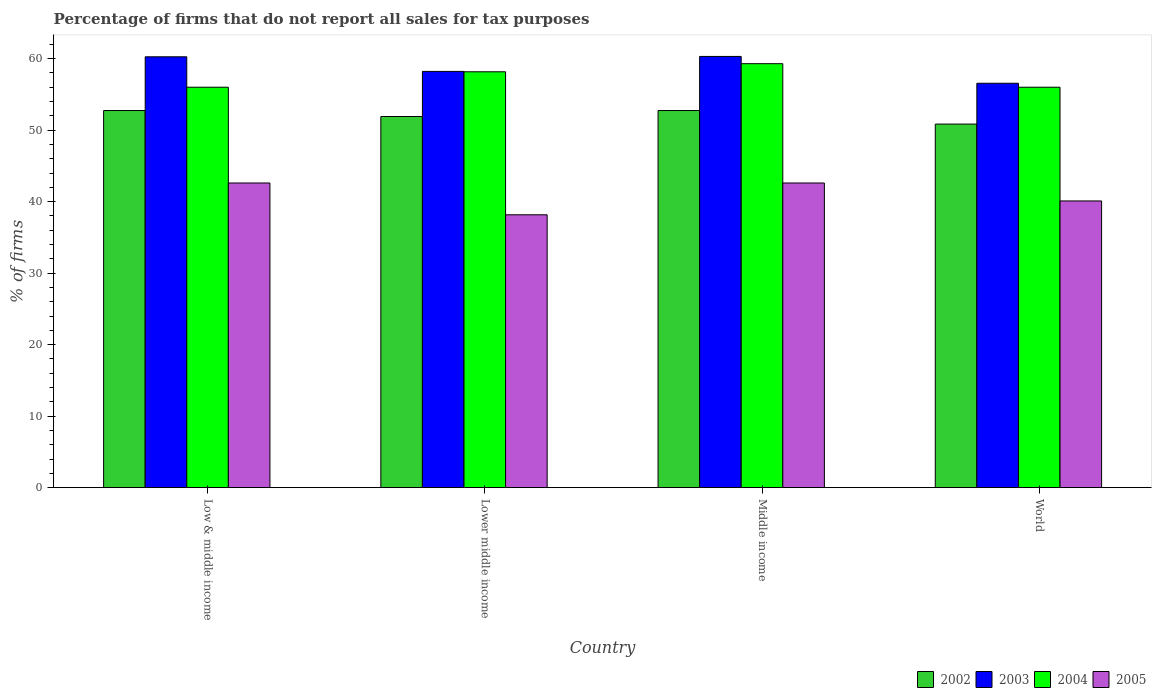Are the number of bars per tick equal to the number of legend labels?
Keep it short and to the point. Yes. Are the number of bars on each tick of the X-axis equal?
Your response must be concise. Yes. How many bars are there on the 4th tick from the right?
Offer a very short reply. 4. What is the label of the 3rd group of bars from the left?
Make the answer very short. Middle income. What is the percentage of firms that do not report all sales for tax purposes in 2005 in Middle income?
Give a very brief answer. 42.61. Across all countries, what is the maximum percentage of firms that do not report all sales for tax purposes in 2003?
Keep it short and to the point. 60.31. Across all countries, what is the minimum percentage of firms that do not report all sales for tax purposes in 2004?
Offer a very short reply. 56.01. In which country was the percentage of firms that do not report all sales for tax purposes in 2005 maximum?
Make the answer very short. Low & middle income. What is the total percentage of firms that do not report all sales for tax purposes in 2003 in the graph?
Offer a very short reply. 235.35. What is the difference between the percentage of firms that do not report all sales for tax purposes in 2003 in Low & middle income and that in Lower middle income?
Give a very brief answer. 2.04. What is the difference between the percentage of firms that do not report all sales for tax purposes in 2004 in Low & middle income and the percentage of firms that do not report all sales for tax purposes in 2002 in World?
Offer a terse response. 5.15. What is the average percentage of firms that do not report all sales for tax purposes in 2004 per country?
Your answer should be very brief. 57.37. What is the difference between the percentage of firms that do not report all sales for tax purposes of/in 2003 and percentage of firms that do not report all sales for tax purposes of/in 2005 in World?
Offer a very short reply. 16.46. What is the ratio of the percentage of firms that do not report all sales for tax purposes in 2002 in Low & middle income to that in World?
Offer a very short reply. 1.04. Is the percentage of firms that do not report all sales for tax purposes in 2003 in Lower middle income less than that in World?
Provide a short and direct response. No. What is the difference between the highest and the second highest percentage of firms that do not report all sales for tax purposes in 2003?
Your answer should be compact. -2.09. What is the difference between the highest and the lowest percentage of firms that do not report all sales for tax purposes in 2005?
Keep it short and to the point. 4.45. Is it the case that in every country, the sum of the percentage of firms that do not report all sales for tax purposes in 2003 and percentage of firms that do not report all sales for tax purposes in 2002 is greater than the sum of percentage of firms that do not report all sales for tax purposes in 2004 and percentage of firms that do not report all sales for tax purposes in 2005?
Make the answer very short. Yes. What does the 2nd bar from the left in Lower middle income represents?
Provide a succinct answer. 2003. Is it the case that in every country, the sum of the percentage of firms that do not report all sales for tax purposes in 2005 and percentage of firms that do not report all sales for tax purposes in 2003 is greater than the percentage of firms that do not report all sales for tax purposes in 2002?
Give a very brief answer. Yes. Are all the bars in the graph horizontal?
Keep it short and to the point. No. Are the values on the major ticks of Y-axis written in scientific E-notation?
Your answer should be very brief. No. Does the graph contain any zero values?
Your response must be concise. No. Does the graph contain grids?
Ensure brevity in your answer.  No. What is the title of the graph?
Ensure brevity in your answer.  Percentage of firms that do not report all sales for tax purposes. What is the label or title of the Y-axis?
Your answer should be very brief. % of firms. What is the % of firms of 2002 in Low & middle income?
Offer a terse response. 52.75. What is the % of firms in 2003 in Low & middle income?
Offer a terse response. 60.26. What is the % of firms of 2004 in Low & middle income?
Give a very brief answer. 56.01. What is the % of firms in 2005 in Low & middle income?
Make the answer very short. 42.61. What is the % of firms in 2002 in Lower middle income?
Ensure brevity in your answer.  51.91. What is the % of firms of 2003 in Lower middle income?
Your response must be concise. 58.22. What is the % of firms in 2004 in Lower middle income?
Give a very brief answer. 58.16. What is the % of firms of 2005 in Lower middle income?
Provide a succinct answer. 38.16. What is the % of firms of 2002 in Middle income?
Give a very brief answer. 52.75. What is the % of firms in 2003 in Middle income?
Keep it short and to the point. 60.31. What is the % of firms in 2004 in Middle income?
Offer a terse response. 59.3. What is the % of firms in 2005 in Middle income?
Provide a short and direct response. 42.61. What is the % of firms in 2002 in World?
Provide a short and direct response. 50.85. What is the % of firms in 2003 in World?
Your answer should be compact. 56.56. What is the % of firms of 2004 in World?
Your answer should be compact. 56.01. What is the % of firms of 2005 in World?
Ensure brevity in your answer.  40.1. Across all countries, what is the maximum % of firms of 2002?
Offer a very short reply. 52.75. Across all countries, what is the maximum % of firms in 2003?
Your response must be concise. 60.31. Across all countries, what is the maximum % of firms in 2004?
Your answer should be compact. 59.3. Across all countries, what is the maximum % of firms of 2005?
Make the answer very short. 42.61. Across all countries, what is the minimum % of firms in 2002?
Your response must be concise. 50.85. Across all countries, what is the minimum % of firms of 2003?
Your answer should be compact. 56.56. Across all countries, what is the minimum % of firms of 2004?
Provide a succinct answer. 56.01. Across all countries, what is the minimum % of firms in 2005?
Offer a terse response. 38.16. What is the total % of firms of 2002 in the graph?
Offer a terse response. 208.25. What is the total % of firms of 2003 in the graph?
Offer a very short reply. 235.35. What is the total % of firms in 2004 in the graph?
Make the answer very short. 229.47. What is the total % of firms of 2005 in the graph?
Offer a terse response. 163.48. What is the difference between the % of firms of 2002 in Low & middle income and that in Lower middle income?
Make the answer very short. 0.84. What is the difference between the % of firms in 2003 in Low & middle income and that in Lower middle income?
Offer a very short reply. 2.04. What is the difference between the % of firms in 2004 in Low & middle income and that in Lower middle income?
Provide a short and direct response. -2.16. What is the difference between the % of firms in 2005 in Low & middle income and that in Lower middle income?
Your response must be concise. 4.45. What is the difference between the % of firms in 2003 in Low & middle income and that in Middle income?
Provide a short and direct response. -0.05. What is the difference between the % of firms of 2004 in Low & middle income and that in Middle income?
Offer a very short reply. -3.29. What is the difference between the % of firms in 2002 in Low & middle income and that in World?
Provide a short and direct response. 1.89. What is the difference between the % of firms of 2005 in Low & middle income and that in World?
Your response must be concise. 2.51. What is the difference between the % of firms in 2002 in Lower middle income and that in Middle income?
Provide a short and direct response. -0.84. What is the difference between the % of firms of 2003 in Lower middle income and that in Middle income?
Offer a very short reply. -2.09. What is the difference between the % of firms of 2004 in Lower middle income and that in Middle income?
Your answer should be very brief. -1.13. What is the difference between the % of firms in 2005 in Lower middle income and that in Middle income?
Keep it short and to the point. -4.45. What is the difference between the % of firms of 2002 in Lower middle income and that in World?
Your response must be concise. 1.06. What is the difference between the % of firms of 2003 in Lower middle income and that in World?
Keep it short and to the point. 1.66. What is the difference between the % of firms of 2004 in Lower middle income and that in World?
Keep it short and to the point. 2.16. What is the difference between the % of firms of 2005 in Lower middle income and that in World?
Your answer should be compact. -1.94. What is the difference between the % of firms in 2002 in Middle income and that in World?
Offer a terse response. 1.89. What is the difference between the % of firms in 2003 in Middle income and that in World?
Offer a terse response. 3.75. What is the difference between the % of firms in 2004 in Middle income and that in World?
Your response must be concise. 3.29. What is the difference between the % of firms in 2005 in Middle income and that in World?
Offer a very short reply. 2.51. What is the difference between the % of firms in 2002 in Low & middle income and the % of firms in 2003 in Lower middle income?
Your response must be concise. -5.47. What is the difference between the % of firms in 2002 in Low & middle income and the % of firms in 2004 in Lower middle income?
Offer a very short reply. -5.42. What is the difference between the % of firms of 2002 in Low & middle income and the % of firms of 2005 in Lower middle income?
Provide a short and direct response. 14.58. What is the difference between the % of firms of 2003 in Low & middle income and the % of firms of 2004 in Lower middle income?
Your response must be concise. 2.1. What is the difference between the % of firms of 2003 in Low & middle income and the % of firms of 2005 in Lower middle income?
Ensure brevity in your answer.  22.1. What is the difference between the % of firms of 2004 in Low & middle income and the % of firms of 2005 in Lower middle income?
Give a very brief answer. 17.84. What is the difference between the % of firms of 2002 in Low & middle income and the % of firms of 2003 in Middle income?
Offer a very short reply. -7.57. What is the difference between the % of firms of 2002 in Low & middle income and the % of firms of 2004 in Middle income?
Give a very brief answer. -6.55. What is the difference between the % of firms of 2002 in Low & middle income and the % of firms of 2005 in Middle income?
Provide a succinct answer. 10.13. What is the difference between the % of firms in 2003 in Low & middle income and the % of firms in 2005 in Middle income?
Ensure brevity in your answer.  17.65. What is the difference between the % of firms of 2004 in Low & middle income and the % of firms of 2005 in Middle income?
Give a very brief answer. 13.39. What is the difference between the % of firms in 2002 in Low & middle income and the % of firms in 2003 in World?
Offer a very short reply. -3.81. What is the difference between the % of firms in 2002 in Low & middle income and the % of firms in 2004 in World?
Your answer should be compact. -3.26. What is the difference between the % of firms of 2002 in Low & middle income and the % of firms of 2005 in World?
Provide a short and direct response. 12.65. What is the difference between the % of firms in 2003 in Low & middle income and the % of firms in 2004 in World?
Ensure brevity in your answer.  4.25. What is the difference between the % of firms of 2003 in Low & middle income and the % of firms of 2005 in World?
Your answer should be compact. 20.16. What is the difference between the % of firms of 2004 in Low & middle income and the % of firms of 2005 in World?
Provide a short and direct response. 15.91. What is the difference between the % of firms in 2002 in Lower middle income and the % of firms in 2003 in Middle income?
Your answer should be compact. -8.4. What is the difference between the % of firms in 2002 in Lower middle income and the % of firms in 2004 in Middle income?
Keep it short and to the point. -7.39. What is the difference between the % of firms of 2002 in Lower middle income and the % of firms of 2005 in Middle income?
Provide a succinct answer. 9.3. What is the difference between the % of firms of 2003 in Lower middle income and the % of firms of 2004 in Middle income?
Make the answer very short. -1.08. What is the difference between the % of firms of 2003 in Lower middle income and the % of firms of 2005 in Middle income?
Offer a very short reply. 15.61. What is the difference between the % of firms of 2004 in Lower middle income and the % of firms of 2005 in Middle income?
Make the answer very short. 15.55. What is the difference between the % of firms of 2002 in Lower middle income and the % of firms of 2003 in World?
Offer a terse response. -4.65. What is the difference between the % of firms in 2002 in Lower middle income and the % of firms in 2004 in World?
Give a very brief answer. -4.1. What is the difference between the % of firms of 2002 in Lower middle income and the % of firms of 2005 in World?
Make the answer very short. 11.81. What is the difference between the % of firms in 2003 in Lower middle income and the % of firms in 2004 in World?
Ensure brevity in your answer.  2.21. What is the difference between the % of firms of 2003 in Lower middle income and the % of firms of 2005 in World?
Ensure brevity in your answer.  18.12. What is the difference between the % of firms in 2004 in Lower middle income and the % of firms in 2005 in World?
Provide a succinct answer. 18.07. What is the difference between the % of firms of 2002 in Middle income and the % of firms of 2003 in World?
Offer a terse response. -3.81. What is the difference between the % of firms of 2002 in Middle income and the % of firms of 2004 in World?
Keep it short and to the point. -3.26. What is the difference between the % of firms in 2002 in Middle income and the % of firms in 2005 in World?
Provide a short and direct response. 12.65. What is the difference between the % of firms of 2003 in Middle income and the % of firms of 2004 in World?
Make the answer very short. 4.31. What is the difference between the % of firms in 2003 in Middle income and the % of firms in 2005 in World?
Offer a terse response. 20.21. What is the difference between the % of firms of 2004 in Middle income and the % of firms of 2005 in World?
Your answer should be very brief. 19.2. What is the average % of firms of 2002 per country?
Provide a short and direct response. 52.06. What is the average % of firms of 2003 per country?
Give a very brief answer. 58.84. What is the average % of firms of 2004 per country?
Keep it short and to the point. 57.37. What is the average % of firms in 2005 per country?
Provide a succinct answer. 40.87. What is the difference between the % of firms of 2002 and % of firms of 2003 in Low & middle income?
Your answer should be compact. -7.51. What is the difference between the % of firms of 2002 and % of firms of 2004 in Low & middle income?
Your answer should be very brief. -3.26. What is the difference between the % of firms in 2002 and % of firms in 2005 in Low & middle income?
Offer a terse response. 10.13. What is the difference between the % of firms of 2003 and % of firms of 2004 in Low & middle income?
Offer a terse response. 4.25. What is the difference between the % of firms of 2003 and % of firms of 2005 in Low & middle income?
Keep it short and to the point. 17.65. What is the difference between the % of firms in 2004 and % of firms in 2005 in Low & middle income?
Keep it short and to the point. 13.39. What is the difference between the % of firms of 2002 and % of firms of 2003 in Lower middle income?
Offer a very short reply. -6.31. What is the difference between the % of firms in 2002 and % of firms in 2004 in Lower middle income?
Keep it short and to the point. -6.26. What is the difference between the % of firms in 2002 and % of firms in 2005 in Lower middle income?
Your answer should be compact. 13.75. What is the difference between the % of firms of 2003 and % of firms of 2004 in Lower middle income?
Keep it short and to the point. 0.05. What is the difference between the % of firms of 2003 and % of firms of 2005 in Lower middle income?
Give a very brief answer. 20.06. What is the difference between the % of firms in 2004 and % of firms in 2005 in Lower middle income?
Provide a succinct answer. 20. What is the difference between the % of firms of 2002 and % of firms of 2003 in Middle income?
Your answer should be very brief. -7.57. What is the difference between the % of firms of 2002 and % of firms of 2004 in Middle income?
Offer a terse response. -6.55. What is the difference between the % of firms of 2002 and % of firms of 2005 in Middle income?
Your answer should be compact. 10.13. What is the difference between the % of firms in 2003 and % of firms in 2004 in Middle income?
Make the answer very short. 1.02. What is the difference between the % of firms in 2003 and % of firms in 2005 in Middle income?
Provide a succinct answer. 17.7. What is the difference between the % of firms in 2004 and % of firms in 2005 in Middle income?
Provide a short and direct response. 16.69. What is the difference between the % of firms of 2002 and % of firms of 2003 in World?
Provide a short and direct response. -5.71. What is the difference between the % of firms in 2002 and % of firms in 2004 in World?
Offer a terse response. -5.15. What is the difference between the % of firms in 2002 and % of firms in 2005 in World?
Offer a very short reply. 10.75. What is the difference between the % of firms in 2003 and % of firms in 2004 in World?
Ensure brevity in your answer.  0.56. What is the difference between the % of firms of 2003 and % of firms of 2005 in World?
Your answer should be compact. 16.46. What is the difference between the % of firms in 2004 and % of firms in 2005 in World?
Your answer should be compact. 15.91. What is the ratio of the % of firms of 2002 in Low & middle income to that in Lower middle income?
Offer a terse response. 1.02. What is the ratio of the % of firms of 2003 in Low & middle income to that in Lower middle income?
Provide a succinct answer. 1.04. What is the ratio of the % of firms in 2004 in Low & middle income to that in Lower middle income?
Give a very brief answer. 0.96. What is the ratio of the % of firms in 2005 in Low & middle income to that in Lower middle income?
Offer a terse response. 1.12. What is the ratio of the % of firms in 2002 in Low & middle income to that in Middle income?
Offer a terse response. 1. What is the ratio of the % of firms in 2003 in Low & middle income to that in Middle income?
Provide a succinct answer. 1. What is the ratio of the % of firms of 2004 in Low & middle income to that in Middle income?
Ensure brevity in your answer.  0.94. What is the ratio of the % of firms in 2002 in Low & middle income to that in World?
Ensure brevity in your answer.  1.04. What is the ratio of the % of firms in 2003 in Low & middle income to that in World?
Make the answer very short. 1.07. What is the ratio of the % of firms of 2005 in Low & middle income to that in World?
Give a very brief answer. 1.06. What is the ratio of the % of firms of 2002 in Lower middle income to that in Middle income?
Your answer should be very brief. 0.98. What is the ratio of the % of firms of 2003 in Lower middle income to that in Middle income?
Ensure brevity in your answer.  0.97. What is the ratio of the % of firms in 2004 in Lower middle income to that in Middle income?
Give a very brief answer. 0.98. What is the ratio of the % of firms in 2005 in Lower middle income to that in Middle income?
Offer a very short reply. 0.9. What is the ratio of the % of firms in 2002 in Lower middle income to that in World?
Keep it short and to the point. 1.02. What is the ratio of the % of firms in 2003 in Lower middle income to that in World?
Provide a short and direct response. 1.03. What is the ratio of the % of firms of 2004 in Lower middle income to that in World?
Give a very brief answer. 1.04. What is the ratio of the % of firms of 2005 in Lower middle income to that in World?
Ensure brevity in your answer.  0.95. What is the ratio of the % of firms of 2002 in Middle income to that in World?
Keep it short and to the point. 1.04. What is the ratio of the % of firms of 2003 in Middle income to that in World?
Offer a very short reply. 1.07. What is the ratio of the % of firms of 2004 in Middle income to that in World?
Your response must be concise. 1.06. What is the ratio of the % of firms of 2005 in Middle income to that in World?
Provide a succinct answer. 1.06. What is the difference between the highest and the second highest % of firms in 2003?
Your answer should be compact. 0.05. What is the difference between the highest and the second highest % of firms in 2004?
Your answer should be compact. 1.13. What is the difference between the highest and the lowest % of firms of 2002?
Your answer should be very brief. 1.89. What is the difference between the highest and the lowest % of firms of 2003?
Provide a succinct answer. 3.75. What is the difference between the highest and the lowest % of firms in 2004?
Provide a short and direct response. 3.29. What is the difference between the highest and the lowest % of firms of 2005?
Your answer should be compact. 4.45. 